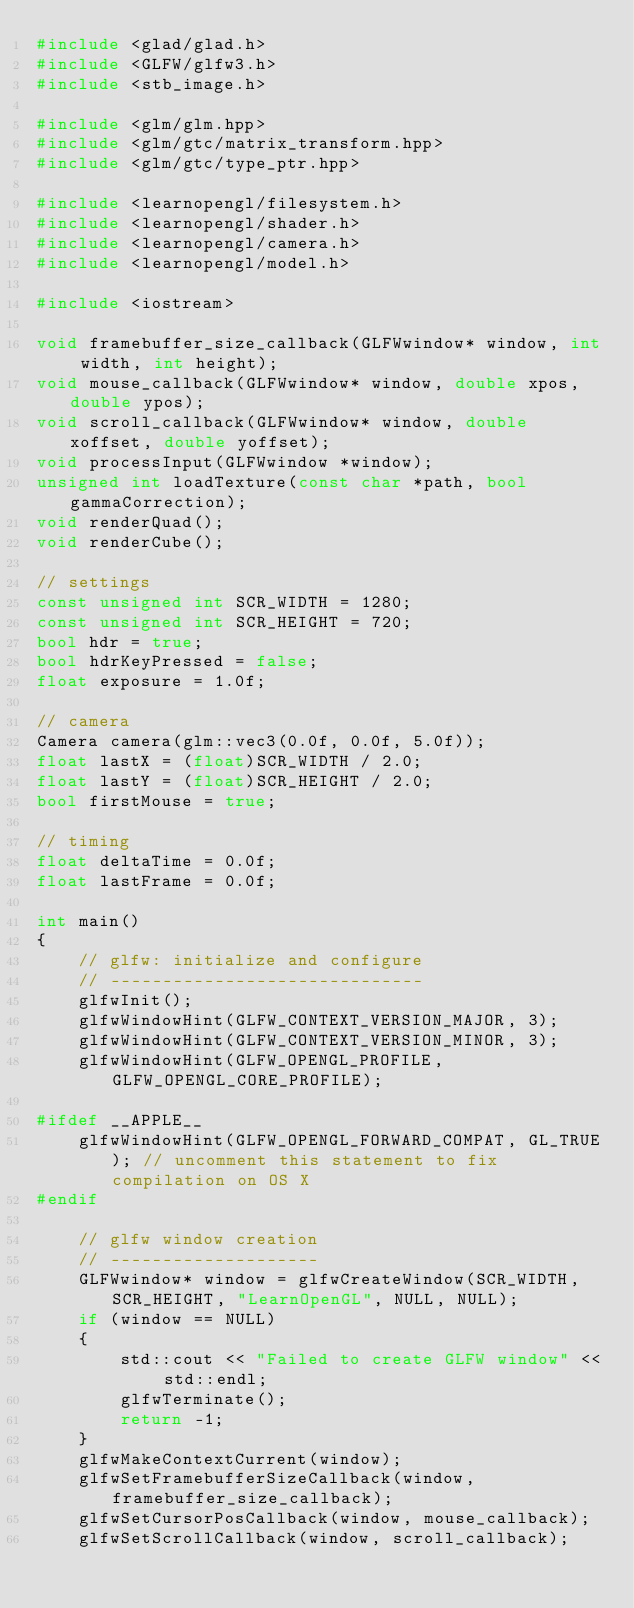<code> <loc_0><loc_0><loc_500><loc_500><_C++_>#include <glad/glad.h>
#include <GLFW/glfw3.h>
#include <stb_image.h>

#include <glm/glm.hpp>
#include <glm/gtc/matrix_transform.hpp>
#include <glm/gtc/type_ptr.hpp>

#include <learnopengl/filesystem.h>
#include <learnopengl/shader.h>
#include <learnopengl/camera.h>
#include <learnopengl/model.h>

#include <iostream>

void framebuffer_size_callback(GLFWwindow* window, int width, int height);
void mouse_callback(GLFWwindow* window, double xpos, double ypos);
void scroll_callback(GLFWwindow* window, double xoffset, double yoffset);
void processInput(GLFWwindow *window);
unsigned int loadTexture(const char *path, bool gammaCorrection);
void renderQuad();
void renderCube();

// settings
const unsigned int SCR_WIDTH = 1280;
const unsigned int SCR_HEIGHT = 720;
bool hdr = true;
bool hdrKeyPressed = false;
float exposure = 1.0f;

// camera
Camera camera(glm::vec3(0.0f, 0.0f, 5.0f));
float lastX = (float)SCR_WIDTH / 2.0;
float lastY = (float)SCR_HEIGHT / 2.0;
bool firstMouse = true;

// timing
float deltaTime = 0.0f;
float lastFrame = 0.0f;

int main()
{
    // glfw: initialize and configure
    // ------------------------------
    glfwInit();
    glfwWindowHint(GLFW_CONTEXT_VERSION_MAJOR, 3);
    glfwWindowHint(GLFW_CONTEXT_VERSION_MINOR, 3);
    glfwWindowHint(GLFW_OPENGL_PROFILE, GLFW_OPENGL_CORE_PROFILE);

#ifdef __APPLE__
    glfwWindowHint(GLFW_OPENGL_FORWARD_COMPAT, GL_TRUE); // uncomment this statement to fix compilation on OS X
#endif

    // glfw window creation
    // --------------------
    GLFWwindow* window = glfwCreateWindow(SCR_WIDTH, SCR_HEIGHT, "LearnOpenGL", NULL, NULL);
    if (window == NULL)
    {
        std::cout << "Failed to create GLFW window" << std::endl;
        glfwTerminate();
        return -1;
    }
    glfwMakeContextCurrent(window);
    glfwSetFramebufferSizeCallback(window, framebuffer_size_callback);
    glfwSetCursorPosCallback(window, mouse_callback);
    glfwSetScrollCallback(window, scroll_callback);
</code> 